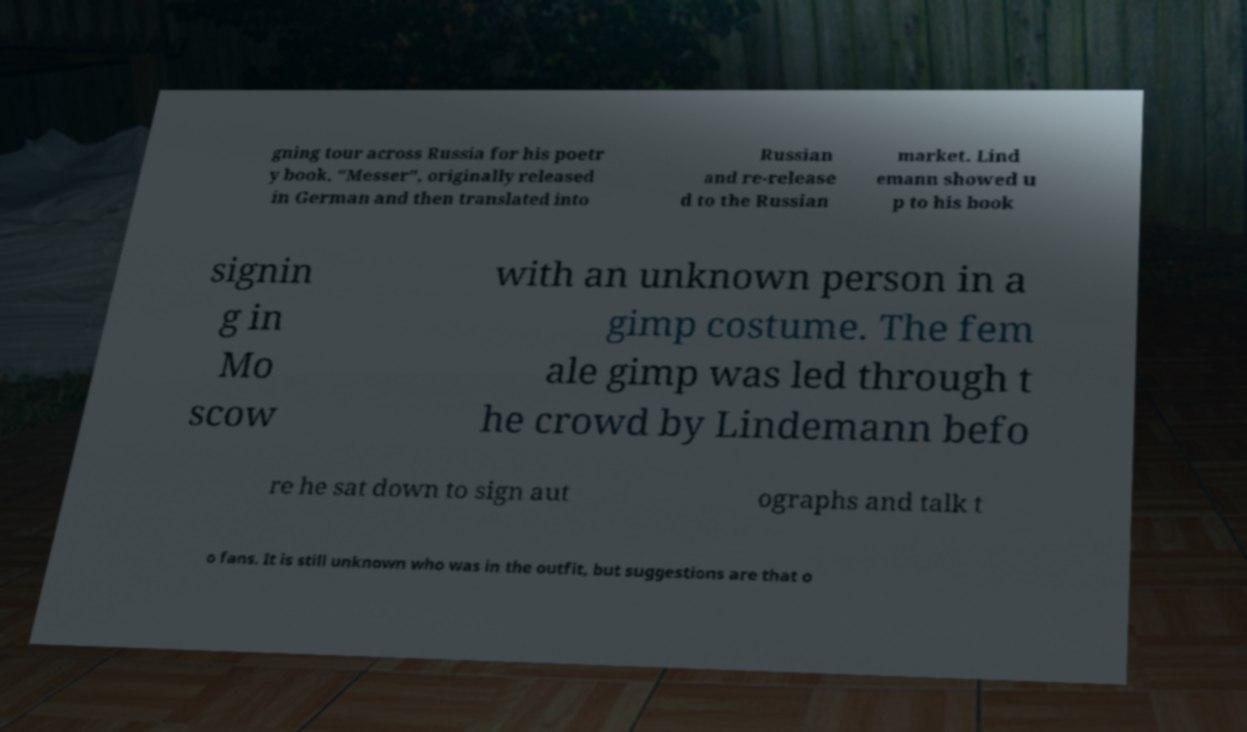There's text embedded in this image that I need extracted. Can you transcribe it verbatim? gning tour across Russia for his poetr y book, "Messer", originally released in German and then translated into Russian and re-release d to the Russian market. Lind emann showed u p to his book signin g in Mo scow with an unknown person in a gimp costume. The fem ale gimp was led through t he crowd by Lindemann befo re he sat down to sign aut ographs and talk t o fans. It is still unknown who was in the outfit, but suggestions are that o 